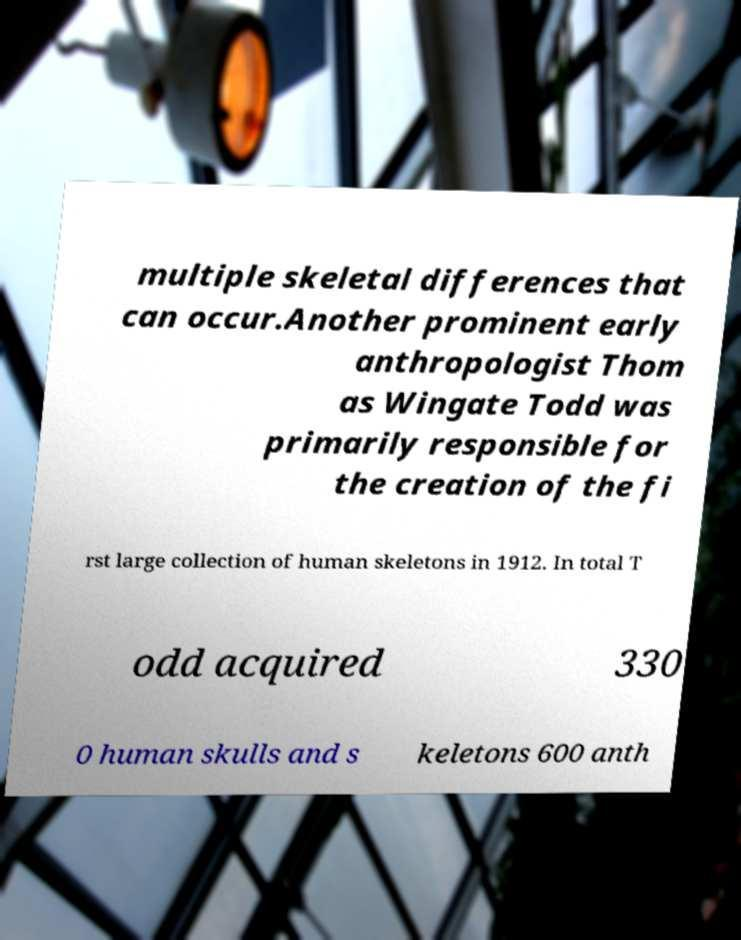Please read and relay the text visible in this image. What does it say? multiple skeletal differences that can occur.Another prominent early anthropologist Thom as Wingate Todd was primarily responsible for the creation of the fi rst large collection of human skeletons in 1912. In total T odd acquired 330 0 human skulls and s keletons 600 anth 